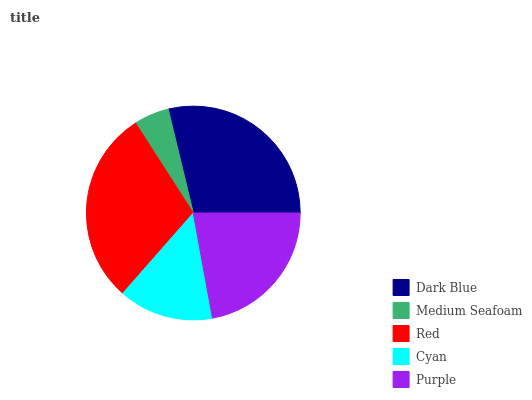Is Medium Seafoam the minimum?
Answer yes or no. Yes. Is Red the maximum?
Answer yes or no. Yes. Is Red the minimum?
Answer yes or no. No. Is Medium Seafoam the maximum?
Answer yes or no. No. Is Red greater than Medium Seafoam?
Answer yes or no. Yes. Is Medium Seafoam less than Red?
Answer yes or no. Yes. Is Medium Seafoam greater than Red?
Answer yes or no. No. Is Red less than Medium Seafoam?
Answer yes or no. No. Is Purple the high median?
Answer yes or no. Yes. Is Purple the low median?
Answer yes or no. Yes. Is Medium Seafoam the high median?
Answer yes or no. No. Is Cyan the low median?
Answer yes or no. No. 